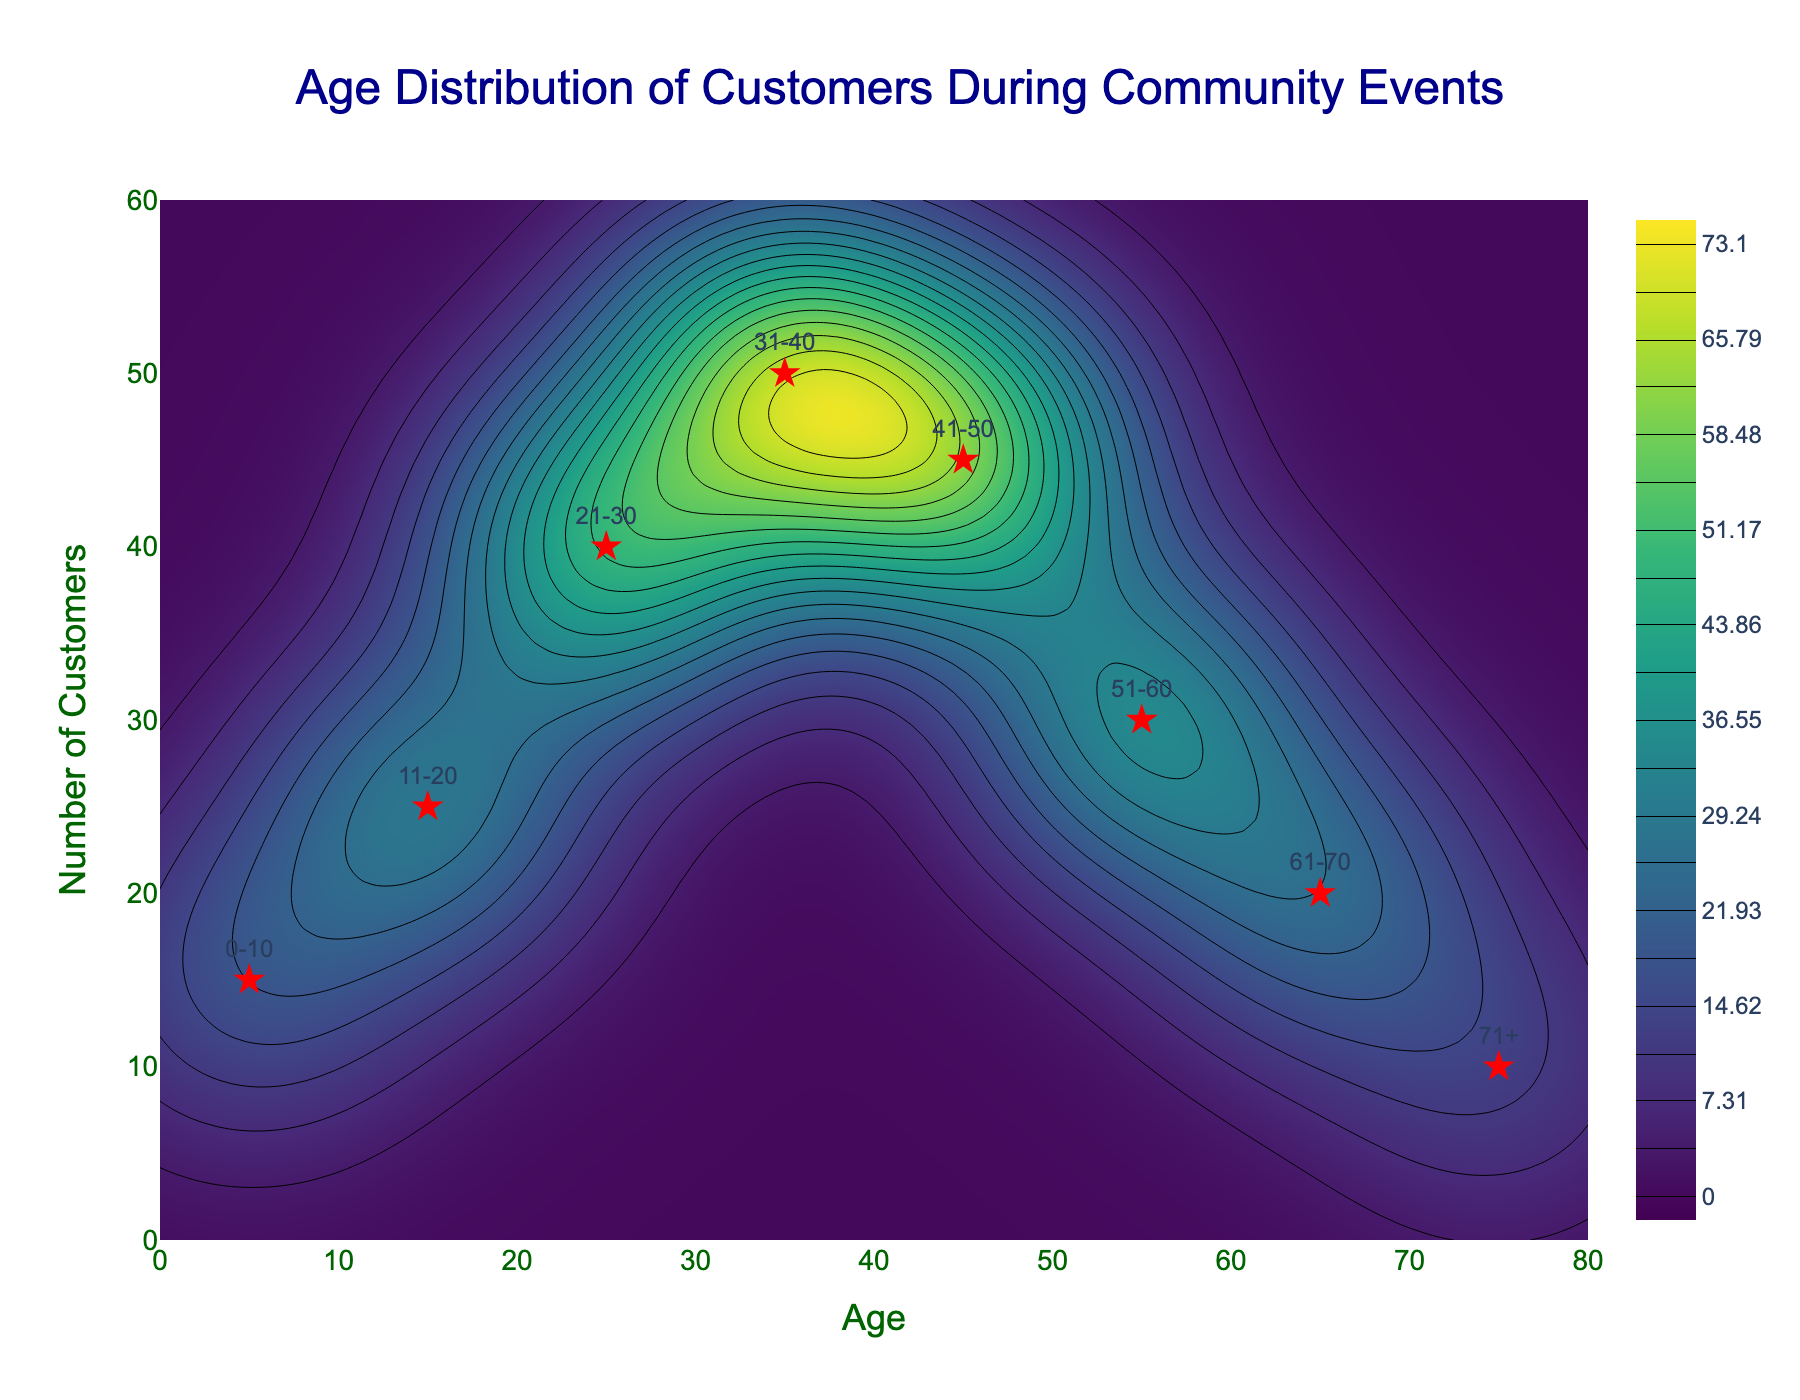What is the title of the figure? The title is displayed at the top center of the figure, indicating the subject of the plot. Here it reads "Age Distribution of Customers During Community Events."
Answer: Age Distribution of Customers During Community Events How many age groups are indicated on the scatter plot? By referring to the scatter plot, there are eight points, each representing an age group.
Answer: 8 What is the age range with the highest number of customers? Look at the scatter plot points and their labels for age ranges. The one with the highest y-value corresponds to the 31-40 age group.
Answer: 31-40 Which age group has the least number of customers? By observing the scatter plot, the point labeled 0-10 and 71+ have the lowest y-values. Both have similar values, but '71+' appears slightly lower in count.
Answer: 71+ What is the total number of customers across all age groups? Add the number of customers from each age group as indicated in the data: 15+25+40+50+45+30+20+10 = 235.
Answer: 235 How does the number of customers in the 41-50 age group compare to the 51-60 age group? The y-value for the 41-50 age group is higher than the 51-60 age group, indicating more customers in the 41-50 range.
Answer: Higher Which age group has a customer count closest to 25? Look at the scatter plot and find the age group corresponding to the y-value closest to 25, which is the 11-20 group.
Answer: 11-20 Which age range shows a steep decline in the number of customers? By tracing the scatter plot from one point to the next, there is a noticeable decline from the 41-50 age group to the 51-60 age group.
Answer: From 41-50 to 51-60 What color is used for the highest density area on the contour plot? The contour plot uses the 'Viridis' color scale, where the highest density area is typically represented by bright yellow.
Answer: Yellow What is the approximate average age range of the customers who attended the events? Calculate the average of the midpoints of each age group weighted by the number of customers. Sum of ages x customers: (5*15 + 15*25 + 25*40 + 35*50 + 45*45 + 55*30 + 65*20 + 75*10) = 7575. Total customers: 235. Average age = 7575 / 235 ≈ 32.2. This corresponds approximately to the 31-40 age range.
Answer: 31-40 